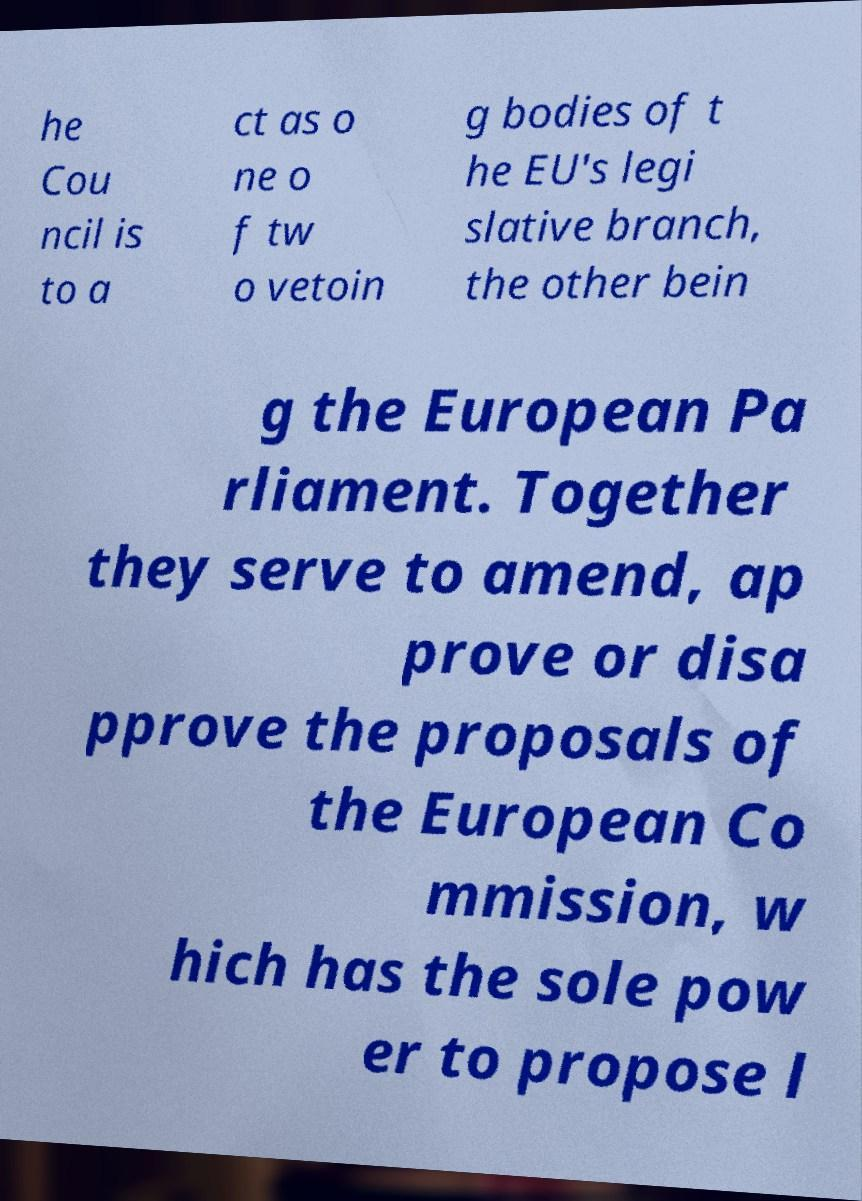I need the written content from this picture converted into text. Can you do that? he Cou ncil is to a ct as o ne o f tw o vetoin g bodies of t he EU's legi slative branch, the other bein g the European Pa rliament. Together they serve to amend, ap prove or disa pprove the proposals of the European Co mmission, w hich has the sole pow er to propose l 